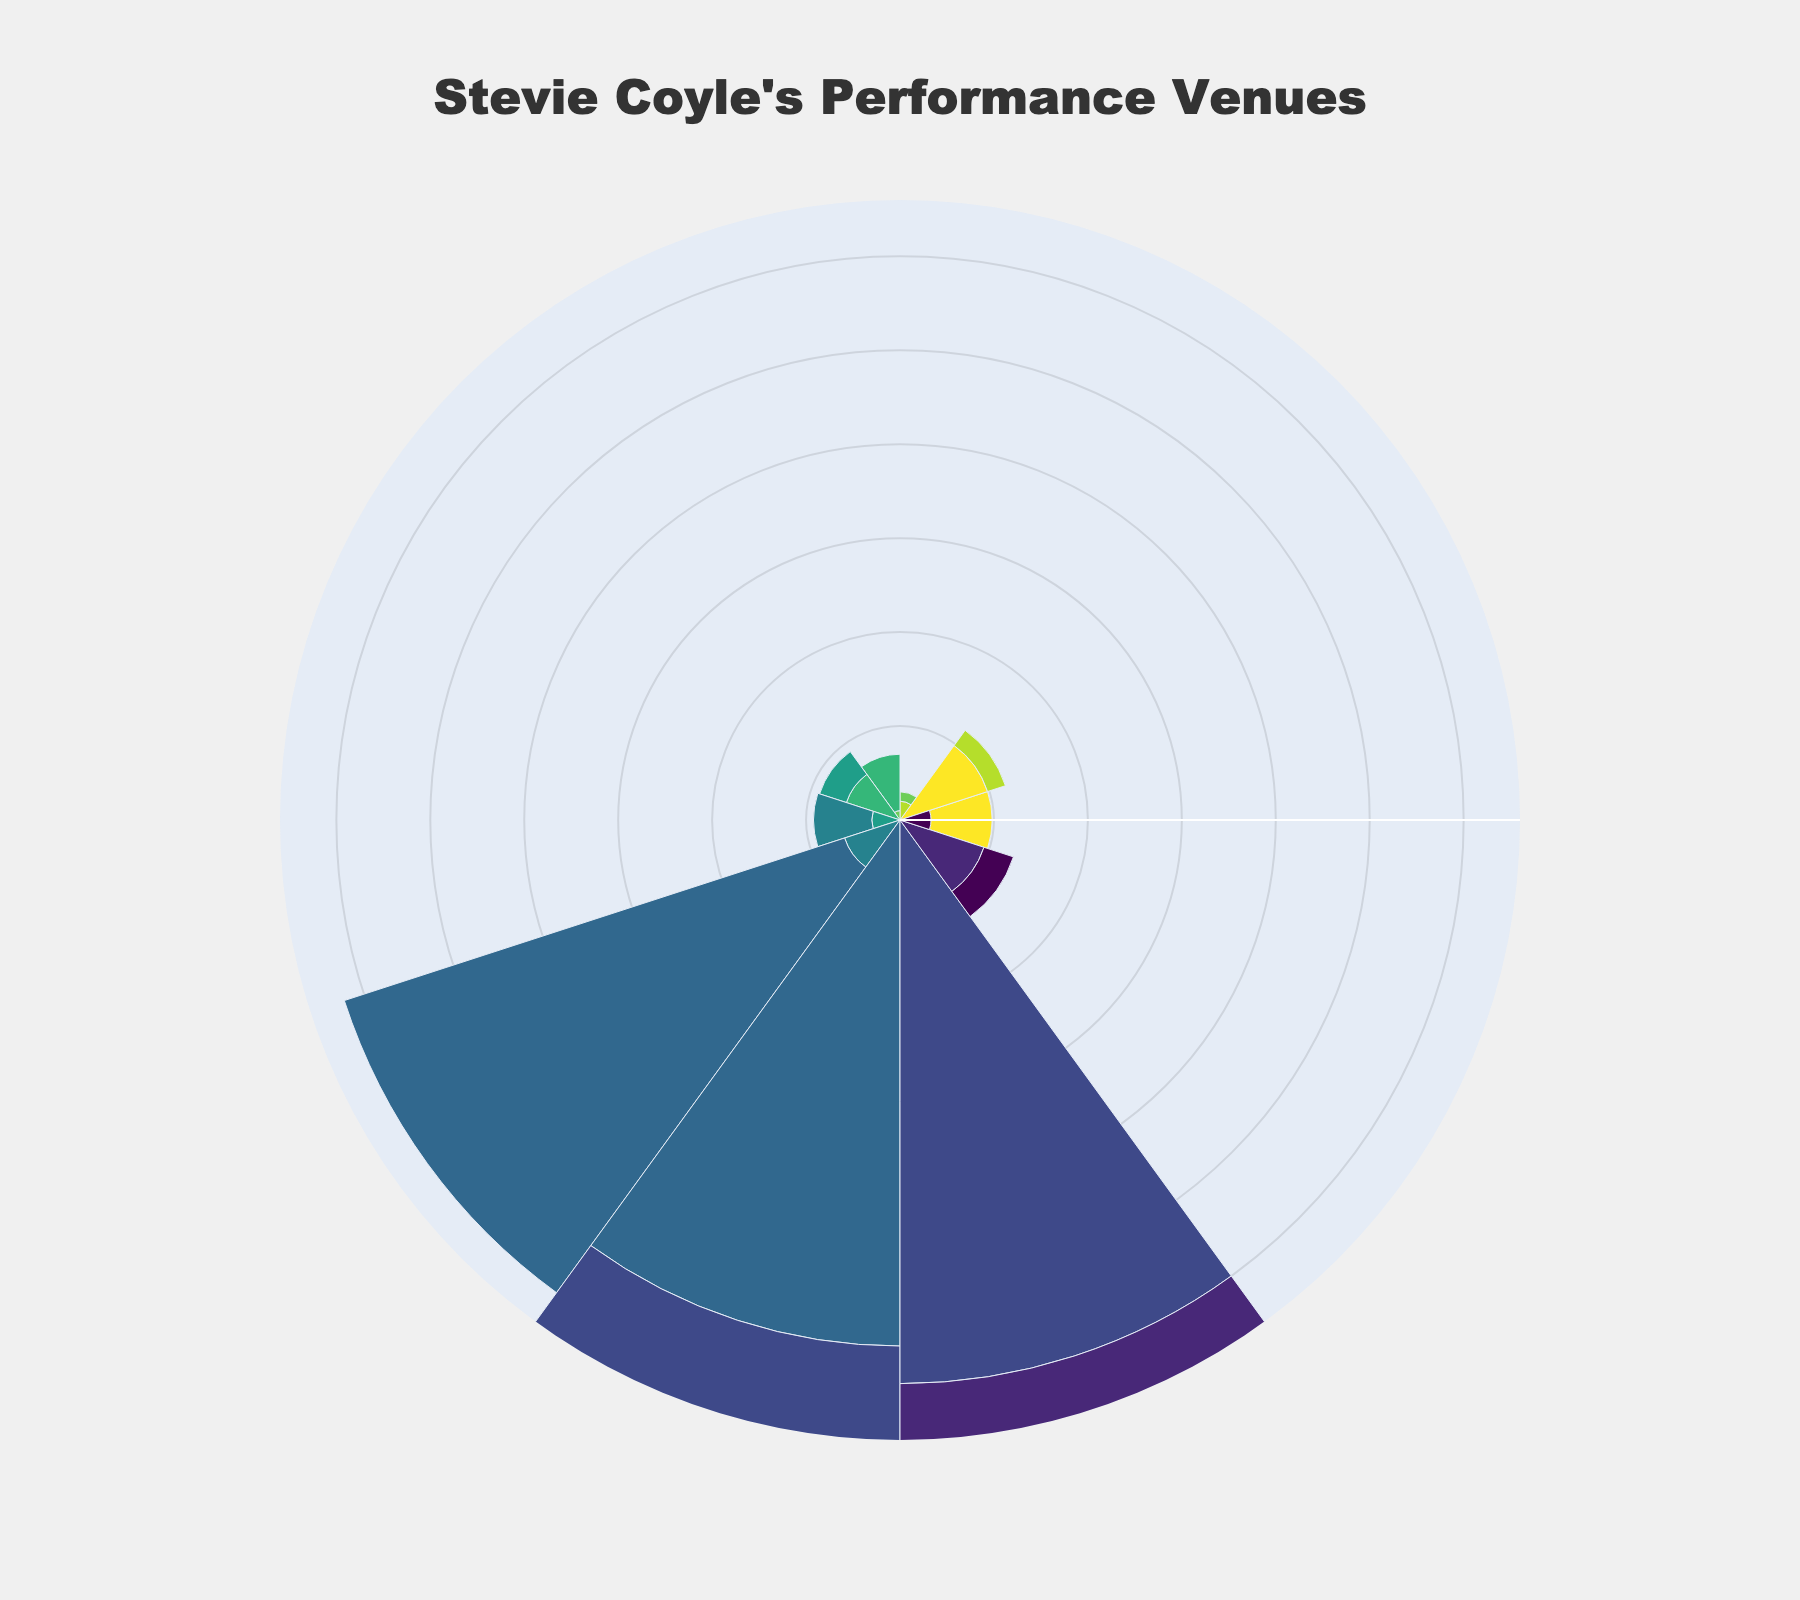What is the title of the fan chart? The fan chart has a main title displayed prominently at the top.
Answer: Stevie Coyle's Performance Venues Which venue has the highest capacity? The capacity values on the fan chart indicate the space size, with the highest value being the one at maximum radius.
Answer: Marin County Fair How many venues have a capacity of 500 or more? Scan the fan chart for venues with radial lengths representing capacities of 500 or above.
Answer: 2 Which location type and venue combination has the most performances? Refer to the hover text or labels indicating venue names and combine it with the number of performances displayed in the chart.
Answer: Bazaar Cafe, Coffee Shop What is the total capacity for all pub venues? Identify the pub locations and sum their capacities: The Starry Plough (100) + Hopmonk Tavern Novato (165) = 100 + 165.
Answer: 265 Which venues have a capacity between 100 and 500? Look for venue radial lengths between the capacities of 100 and 500 units.
Answer: Freight & Salvage, The Starry Plough, Sweetwater Music Hall, Fenix, Yoshi's Oakland, Great American Music Hall, Hopmonk Tavern Novato Which venue has the smallest capacity and how many performances does it have? Find the fan segment with the shortest radial length representing the smallest capacity and look at the performance count.
Answer: Bazaar Cafe, 20 What is the average capacity of the concert hall venues? There is only one concert hall, Freight & Salvage, so the capacity is 490.
Answer: 490 What is the total number of performances at the venues listed? Sum the number of performances across all venues: 15 + 8 + 20 + 12 + 6 + 4 + 2 + 3 + 5 + 10.
Answer: 85 Compare the number of performances at the music venue and the theater. Which is higher? Compare the two specific segments: Sweetwater Music Hall (music venue, 12 performances) and Fox Theatre (theater, 2 performances).
Answer: Music venue has higher performances 